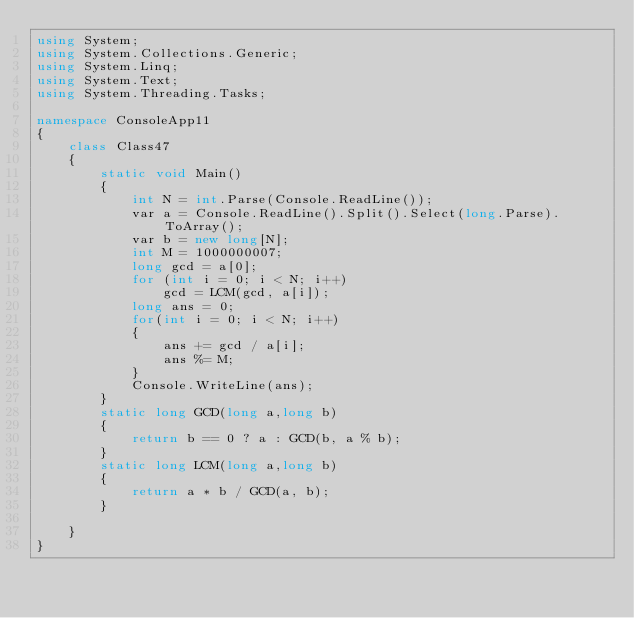<code> <loc_0><loc_0><loc_500><loc_500><_C#_>using System;
using System.Collections.Generic;
using System.Linq;
using System.Text;
using System.Threading.Tasks;

namespace ConsoleApp11
{
    class Class47
    {
        static void Main()
        {
            int N = int.Parse(Console.ReadLine());
            var a = Console.ReadLine().Split().Select(long.Parse).ToArray();
            var b = new long[N];
            int M = 1000000007;
            long gcd = a[0];
            for (int i = 0; i < N; i++)
                gcd = LCM(gcd, a[i]);
            long ans = 0;
            for(int i = 0; i < N; i++)
            {
                ans += gcd / a[i];
                ans %= M;
            }
            Console.WriteLine(ans);
        }
        static long GCD(long a,long b)
        {
            return b == 0 ? a : GCD(b, a % b);
        }
        static long LCM(long a,long b)
        {
            return a * b / GCD(a, b);
        }
         
    }
}
</code> 